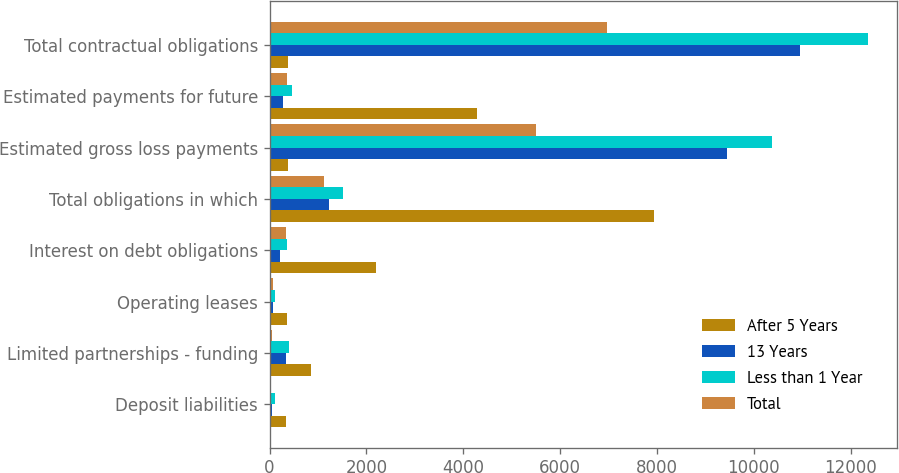Convert chart. <chart><loc_0><loc_0><loc_500><loc_500><stacked_bar_chart><ecel><fcel>Deposit liabilities<fcel>Limited partnerships - funding<fcel>Operating leases<fcel>Interest on debt obligations<fcel>Total obligations in which<fcel>Estimated gross loss payments<fcel>Estimated payments for future<fcel>Total contractual obligations<nl><fcel>After 5 Years<fcel>345<fcel>863<fcel>351<fcel>2196<fcel>7936<fcel>388.5<fcel>4280<fcel>388.5<nl><fcel>13 Years<fcel>44<fcel>334<fcel>68<fcel>210<fcel>1235<fcel>9445<fcel>284<fcel>10964<nl><fcel>Less than 1 Year<fcel>112<fcel>408<fcel>108<fcel>369<fcel>1518<fcel>10371<fcel>461<fcel>12350<nl><fcel>Total<fcel>30<fcel>58<fcel>75<fcel>342<fcel>1120<fcel>5493<fcel>366<fcel>6979<nl></chart> 